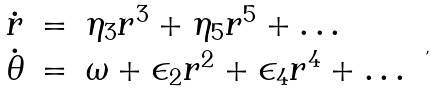Convert formula to latex. <formula><loc_0><loc_0><loc_500><loc_500>\begin{array} { l l l } \dot { r } & = & \eta _ { 3 } r ^ { 3 } + \eta _ { 5 } r ^ { 5 } + \dots \\ \dot { \theta } & = & \omega + \epsilon _ { 2 } r ^ { 2 } + \epsilon _ { 4 } r ^ { 4 } + \dots \end{array} \ ,</formula> 